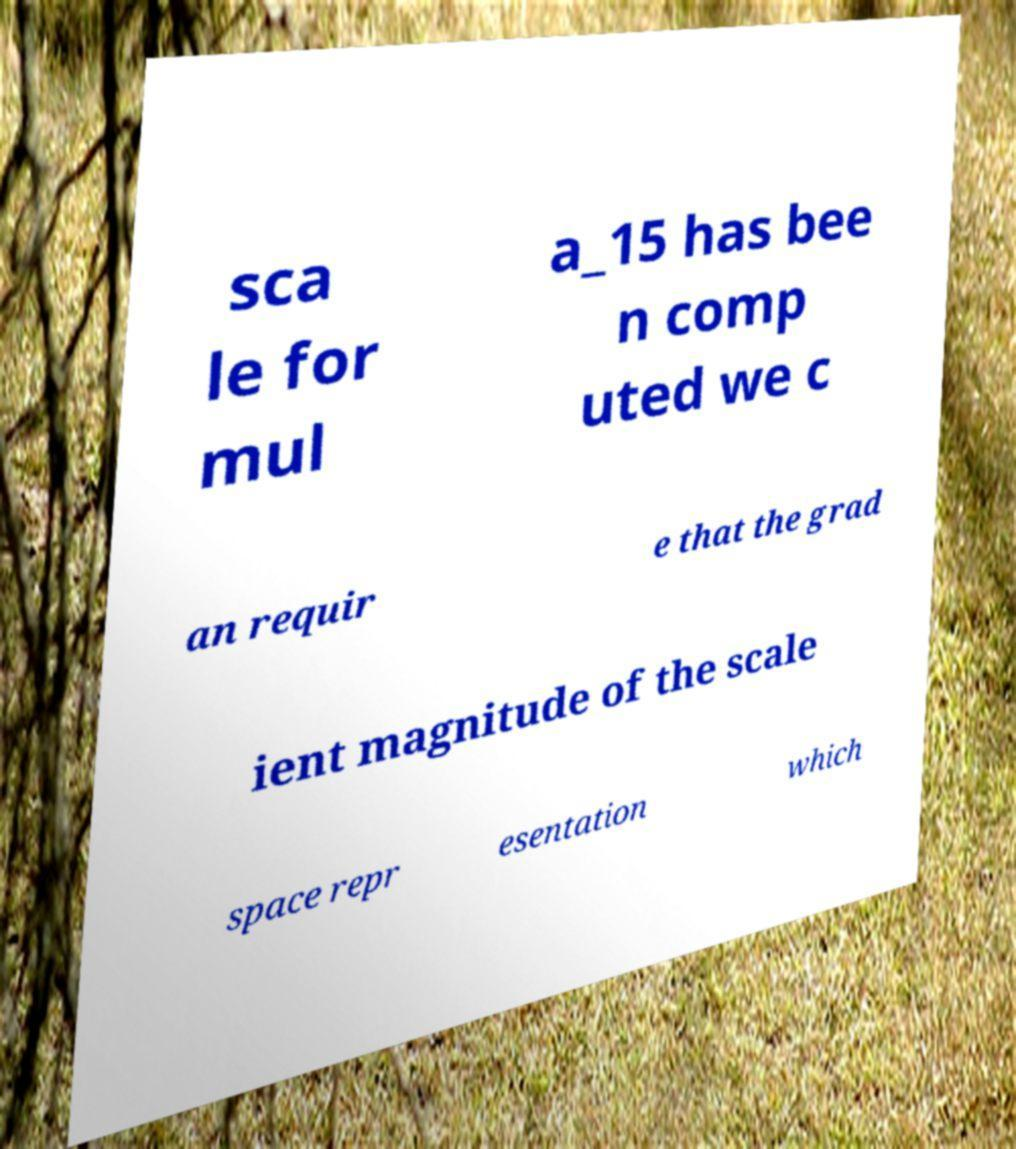I need the written content from this picture converted into text. Can you do that? sca le for mul a_15 has bee n comp uted we c an requir e that the grad ient magnitude of the scale space repr esentation which 